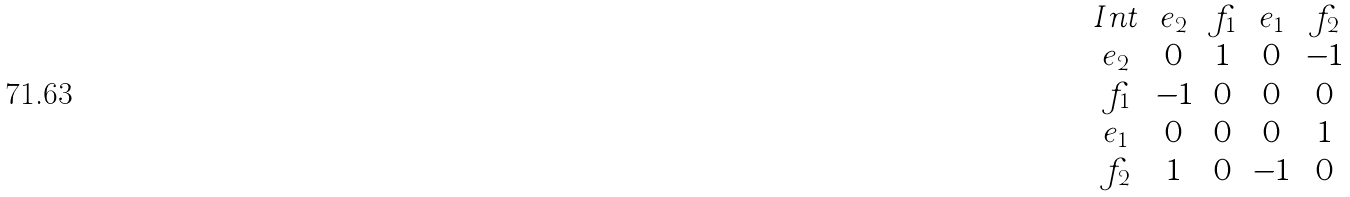Convert formula to latex. <formula><loc_0><loc_0><loc_500><loc_500>\begin{array} { c c c c c } I n t & e _ { 2 } & f _ { 1 } & e _ { 1 } & f _ { 2 } \\ e _ { 2 } & 0 & 1 & 0 & - 1 \\ f _ { 1 } & - 1 & 0 & 0 & 0 \\ e _ { 1 } & 0 & 0 & 0 & 1 \\ f _ { 2 } & 1 & 0 & - 1 & 0 \end{array}</formula> 